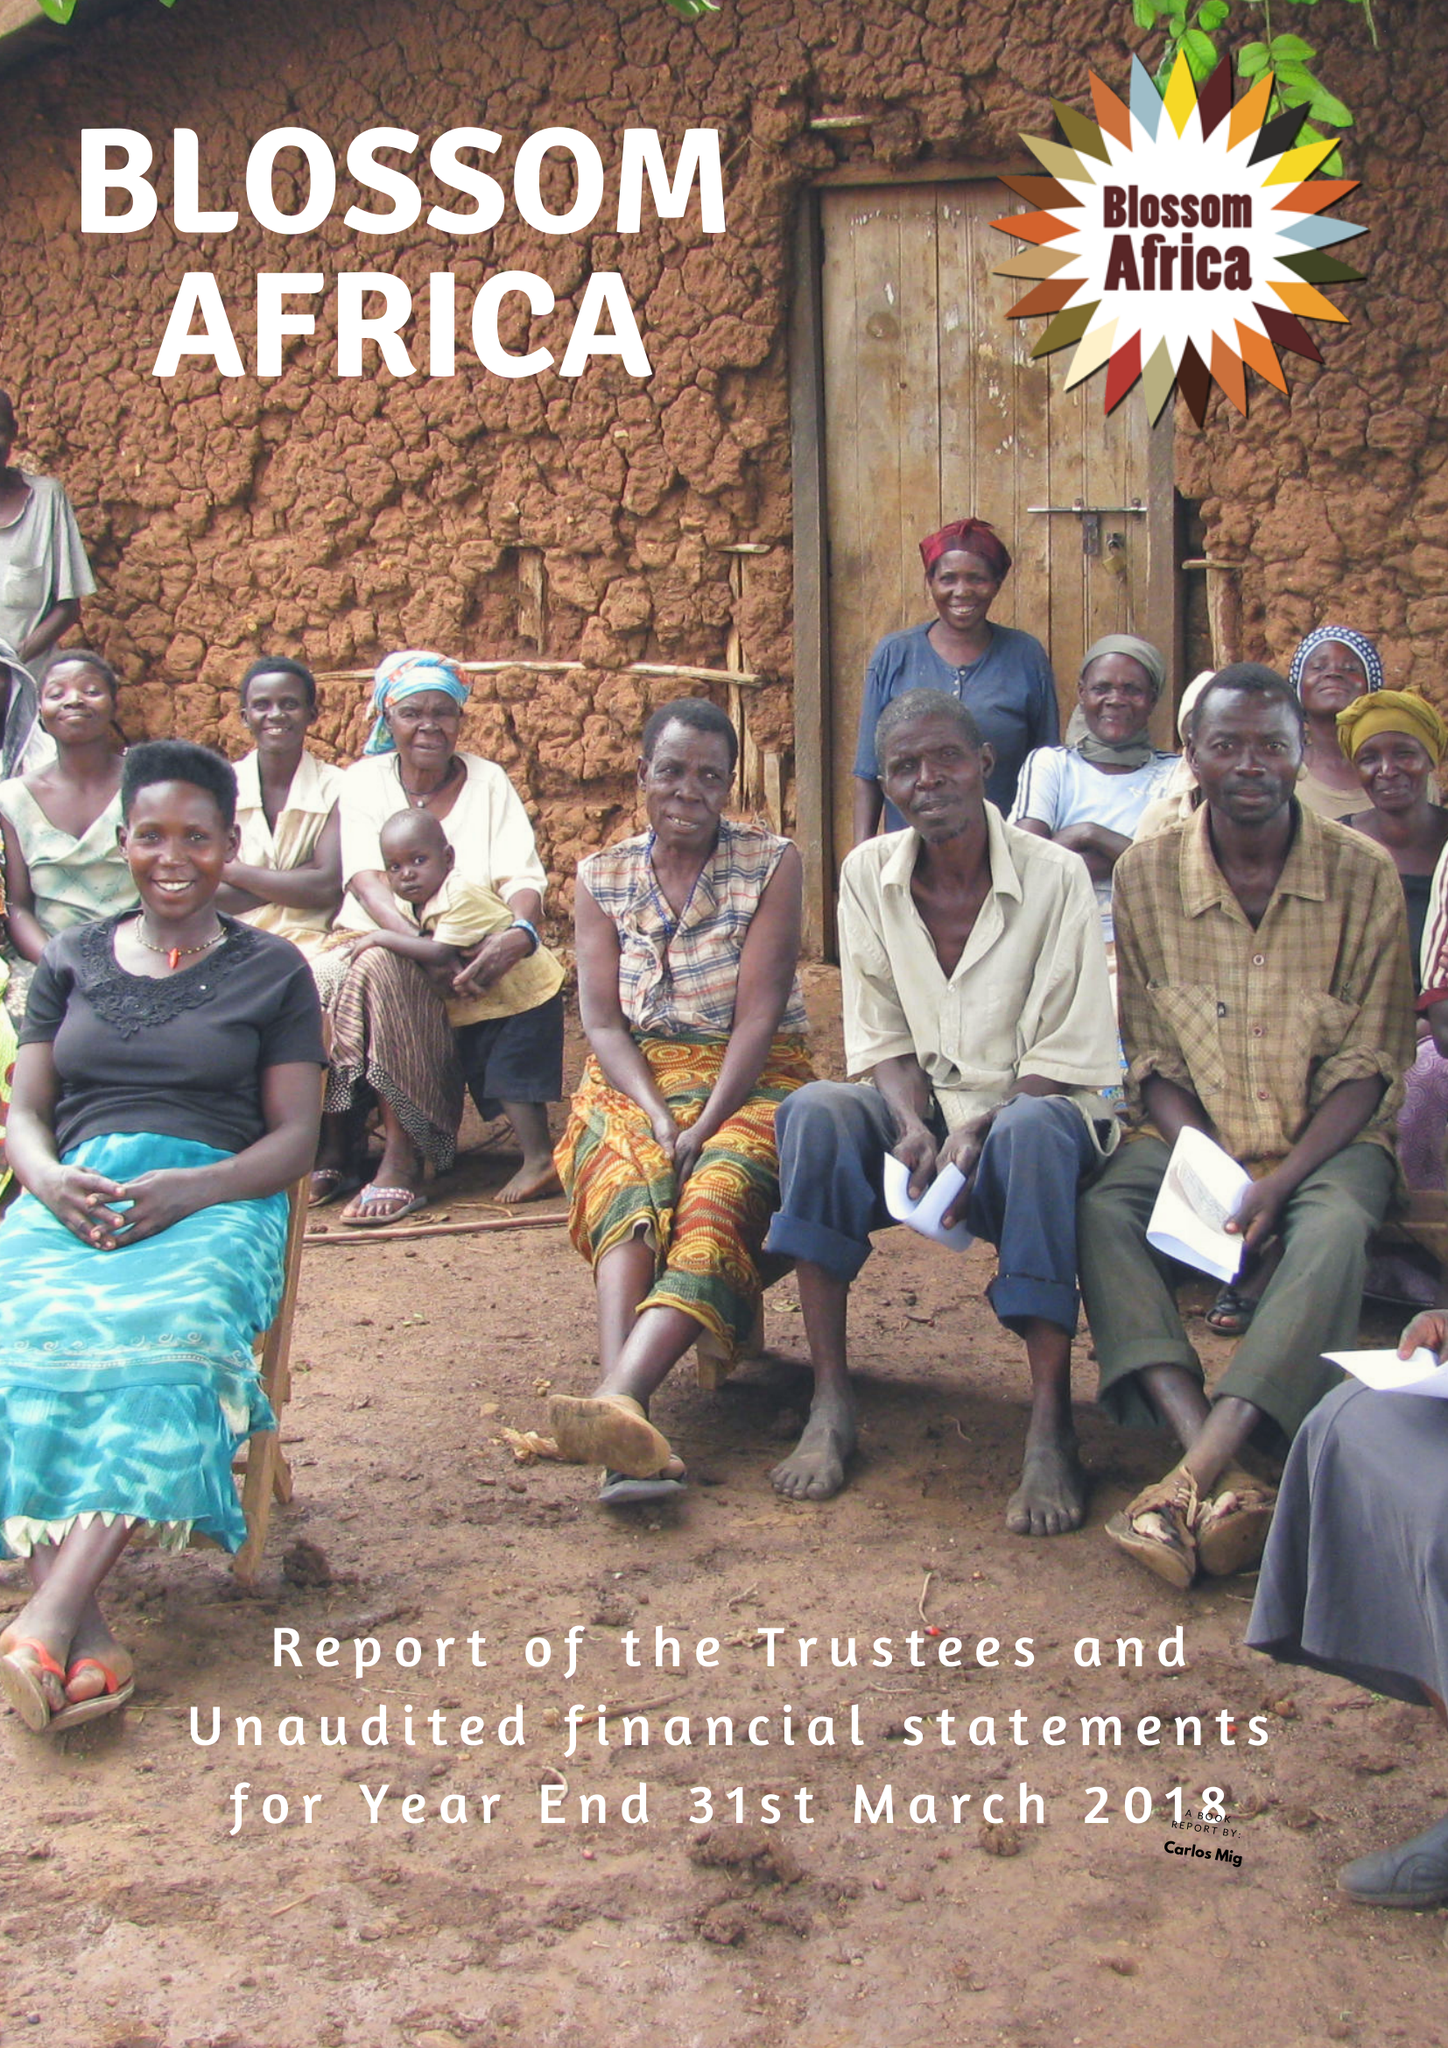What is the value for the address__post_town?
Answer the question using a single word or phrase. NEWPORT 